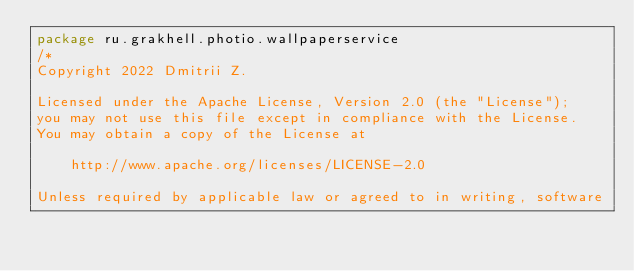Convert code to text. <code><loc_0><loc_0><loc_500><loc_500><_Kotlin_>package ru.grakhell.photio.wallpaperservice
/*
Copyright 2022 Dmitrii Z.

Licensed under the Apache License, Version 2.0 (the "License");
you may not use this file except in compliance with the License.
You may obtain a copy of the License at

    http://www.apache.org/licenses/LICENSE-2.0

Unless required by applicable law or agreed to in writing, software</code> 